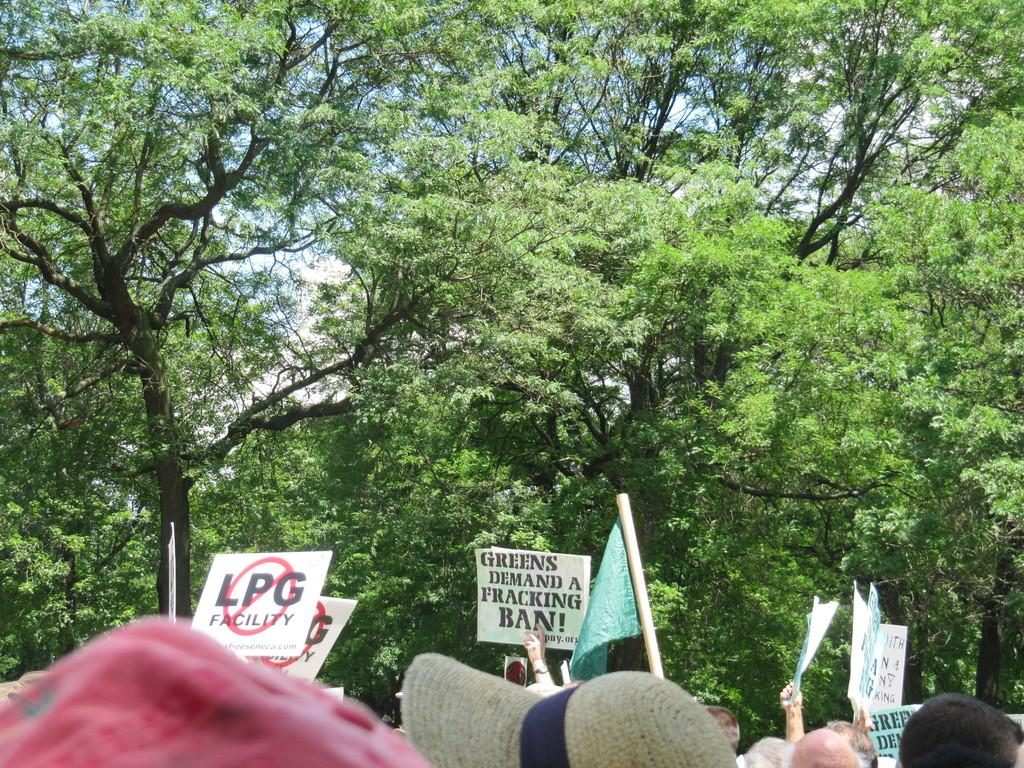How many people are in the image? There is a group of people in the image, but the exact number is not specified. What are the people holding in the image? The people are holding placards in the image. What can be seen in the image besides the people and placards? There is a flag in the image. What is visible in the background of the image? Trees and the sky are visible in the background of the image. How many trucks are parked behind the trees in the image? There are no trucks visible in the image; only trees and the sky are present in the background. 